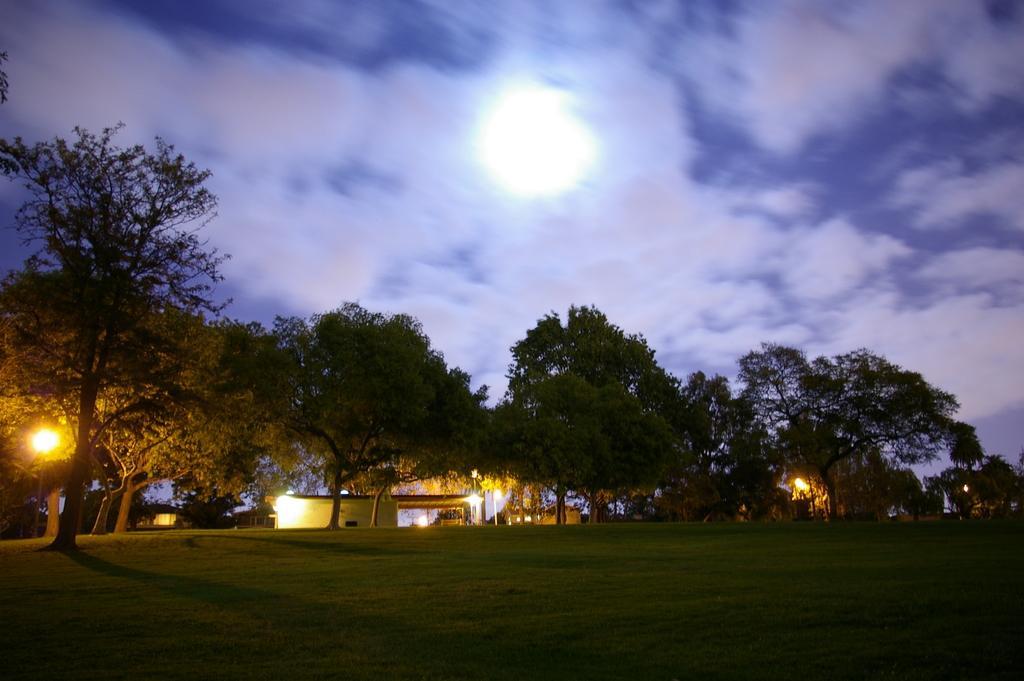Describe this image in one or two sentences. In this image we can see the trees, houses, lights and also the grass at the bottom. In the background we can see the sky with the clouds. We can also see the full moon. 